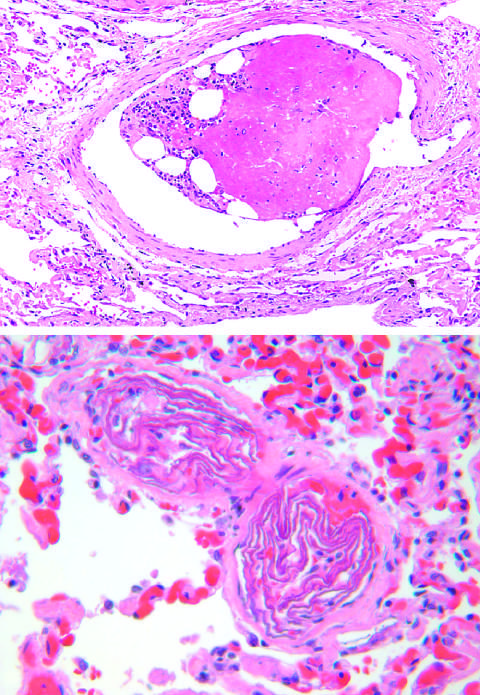s the embolus composed of hematopoietic marrow and marrow fat cells attached to a thrombus?
Answer the question using a single word or phrase. Yes 